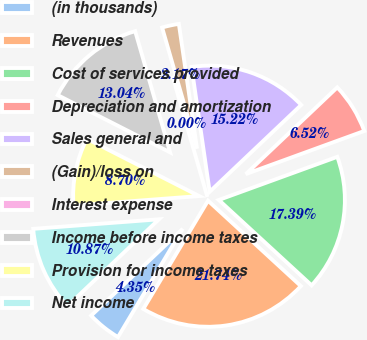Convert chart to OTSL. <chart><loc_0><loc_0><loc_500><loc_500><pie_chart><fcel>(in thousands)<fcel>Revenues<fcel>Cost of services provided<fcel>Depreciation and amortization<fcel>Sales general and<fcel>(Gain)/loss on<fcel>Interest expense<fcel>Income before income taxes<fcel>Provision for income taxes<fcel>Net income<nl><fcel>4.35%<fcel>21.74%<fcel>17.39%<fcel>6.52%<fcel>15.22%<fcel>2.17%<fcel>0.0%<fcel>13.04%<fcel>8.7%<fcel>10.87%<nl></chart> 